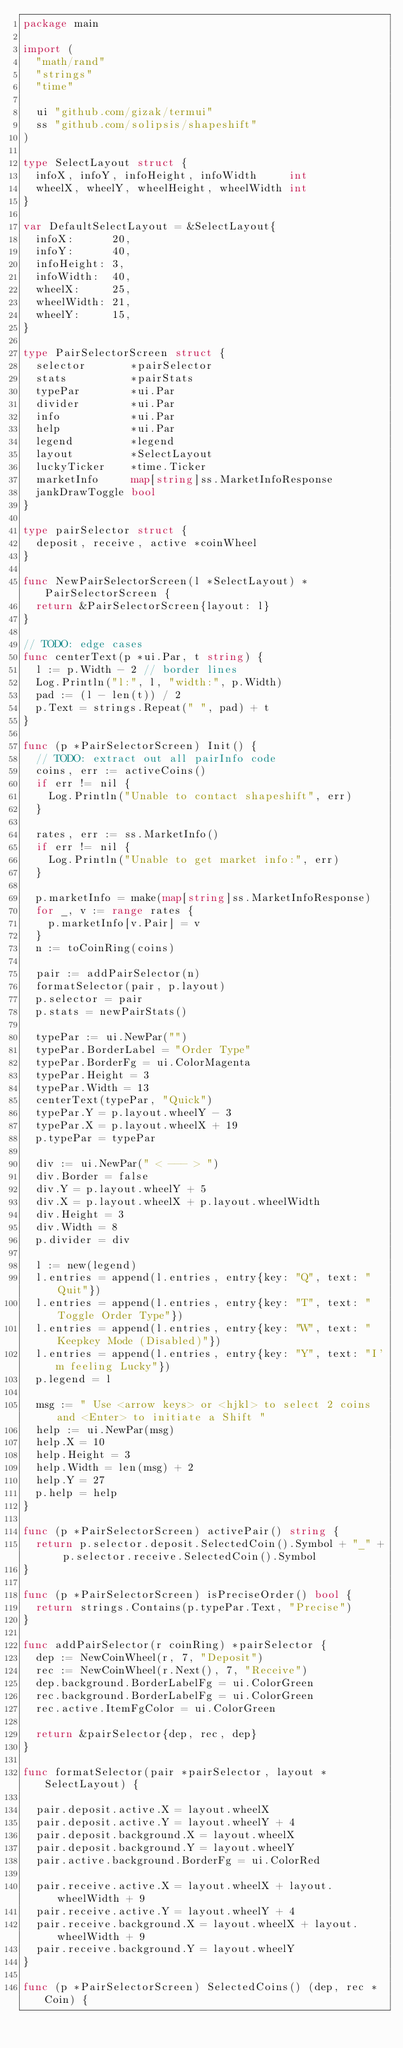<code> <loc_0><loc_0><loc_500><loc_500><_Go_>package main

import (
	"math/rand"
	"strings"
	"time"

	ui "github.com/gizak/termui"
	ss "github.com/solipsis/shapeshift"
)

type SelectLayout struct {
	infoX, infoY, infoHeight, infoWidth     int
	wheelX, wheelY, wheelHeight, wheelWidth int
}

var DefaultSelectLayout = &SelectLayout{
	infoX:      20,
	infoY:      40,
	infoHeight: 3,
	infoWidth:  40,
	wheelX:     25,
	wheelWidth: 21,
	wheelY:     15,
}

type PairSelectorScreen struct {
	selector       *pairSelector
	stats          *pairStats
	typePar        *ui.Par
	divider        *ui.Par
	info           *ui.Par
	help           *ui.Par
	legend         *legend
	layout         *SelectLayout
	luckyTicker    *time.Ticker
	marketInfo     map[string]ss.MarketInfoResponse
	jankDrawToggle bool
}

type pairSelector struct {
	deposit, receive, active *coinWheel
}

func NewPairSelectorScreen(l *SelectLayout) *PairSelectorScreen {
	return &PairSelectorScreen{layout: l}
}

// TODO: edge cases
func centerText(p *ui.Par, t string) {
	l := p.Width - 2 // border lines
	Log.Println("l:", l, "width:", p.Width)
	pad := (l - len(t)) / 2
	p.Text = strings.Repeat(" ", pad) + t
}

func (p *PairSelectorScreen) Init() {
	// TODO: extract out all pairInfo code
	coins, err := activeCoins()
	if err != nil {
		Log.Println("Unable to contact shapeshift", err)
	}

	rates, err := ss.MarketInfo()
	if err != nil {
		Log.Println("Unable to get market info:", err)
	}

	p.marketInfo = make(map[string]ss.MarketInfoResponse)
	for _, v := range rates {
		p.marketInfo[v.Pair] = v
	}
	n := toCoinRing(coins)

	pair := addPairSelector(n)
	formatSelector(pair, p.layout)
	p.selector = pair
	p.stats = newPairStats()

	typePar := ui.NewPar("")
	typePar.BorderLabel = "Order Type"
	typePar.BorderFg = ui.ColorMagenta
	typePar.Height = 3
	typePar.Width = 13
	centerText(typePar, "Quick")
	typePar.Y = p.layout.wheelY - 3
	typePar.X = p.layout.wheelX + 19
	p.typePar = typePar

	div := ui.NewPar(" < --- > ")
	div.Border = false
	div.Y = p.layout.wheelY + 5
	div.X = p.layout.wheelX + p.layout.wheelWidth
	div.Height = 3
	div.Width = 8
	p.divider = div

	l := new(legend)
	l.entries = append(l.entries, entry{key: "Q", text: "Quit"})
	l.entries = append(l.entries, entry{key: "T", text: "Toggle Order Type"})
	l.entries = append(l.entries, entry{key: "W", text: "Keepkey Mode (Disabled)"})
	l.entries = append(l.entries, entry{key: "Y", text: "I'm feeling Lucky"})
	p.legend = l

	msg := " Use <arrow keys> or <hjkl> to select 2 coins and <Enter> to initiate a Shift "
	help := ui.NewPar(msg)
	help.X = 10
	help.Height = 3
	help.Width = len(msg) + 2
	help.Y = 27
	p.help = help
}

func (p *PairSelectorScreen) activePair() string {
	return p.selector.deposit.SelectedCoin().Symbol + "_" + p.selector.receive.SelectedCoin().Symbol
}

func (p *PairSelectorScreen) isPreciseOrder() bool {
	return strings.Contains(p.typePar.Text, "Precise")
}

func addPairSelector(r coinRing) *pairSelector {
	dep := NewCoinWheel(r, 7, "Deposit")
	rec := NewCoinWheel(r.Next(), 7, "Receive")
	dep.background.BorderLabelFg = ui.ColorGreen
	rec.background.BorderLabelFg = ui.ColorGreen
	rec.active.ItemFgColor = ui.ColorGreen

	return &pairSelector{dep, rec, dep}
}

func formatSelector(pair *pairSelector, layout *SelectLayout) {

	pair.deposit.active.X = layout.wheelX
	pair.deposit.active.Y = layout.wheelY + 4
	pair.deposit.background.X = layout.wheelX
	pair.deposit.background.Y = layout.wheelY
	pair.active.background.BorderFg = ui.ColorRed

	pair.receive.active.X = layout.wheelX + layout.wheelWidth + 9
	pair.receive.active.Y = layout.wheelY + 4
	pair.receive.background.X = layout.wheelX + layout.wheelWidth + 9
	pair.receive.background.Y = layout.wheelY
}

func (p *PairSelectorScreen) SelectedCoins() (dep, rec *Coin) {</code> 